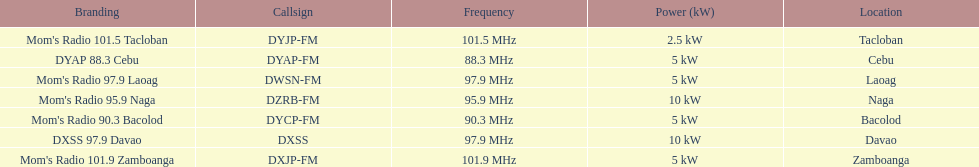What are the total number of radio stations on this list? 7. 